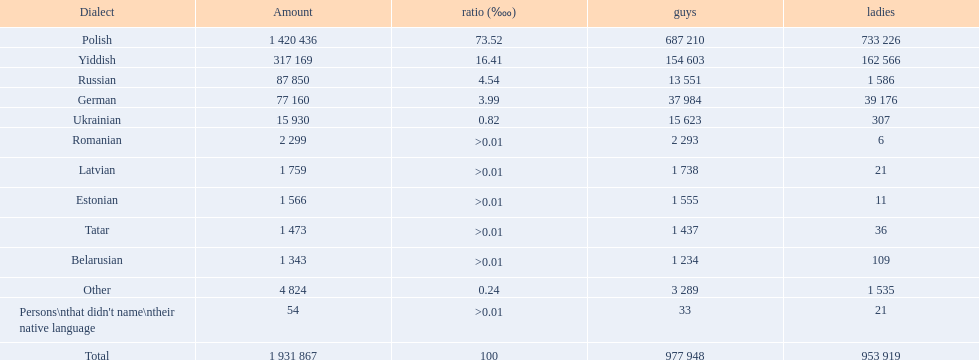What are all of the languages used in the warsaw governorate? Polish, Yiddish, Russian, German, Ukrainian, Romanian, Latvian, Estonian, Tatar, Belarusian, Other, Persons\nthat didn't name\ntheir native language. Which language was comprised of the least number of female speakers? Romanian. 